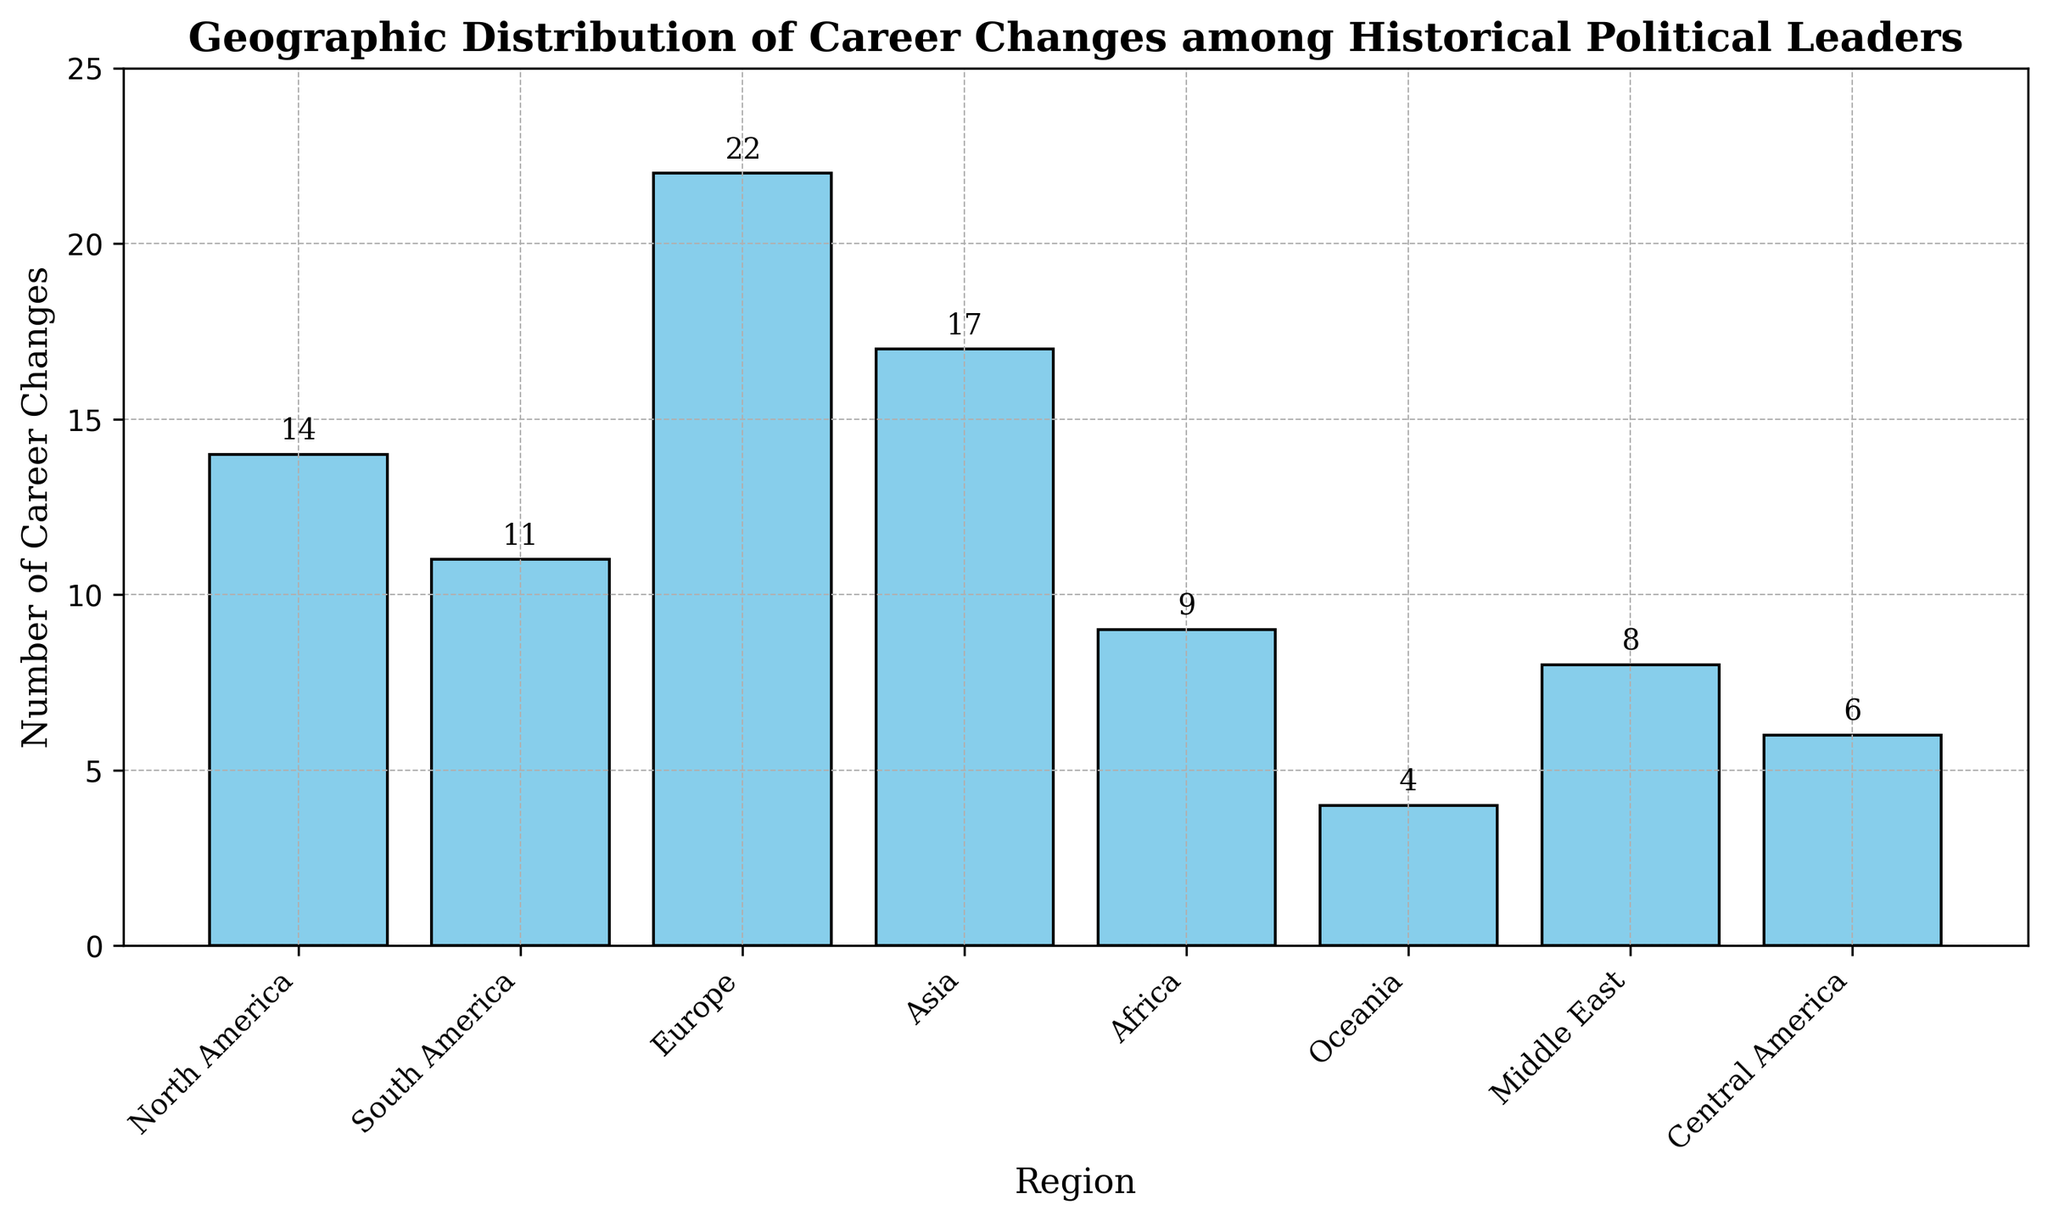What region had the highest number of career changes among historical political leaders? The region with the tallest bar represents the highest number of career changes. From the figure, Europe has the tallest bar, indicating it has the highest number of career changes.
Answer: Europe Compare the number of career changes between Asia and Africa. Which one is greater, and by how much? The height of the bar for Asia is 17 and for Africa is 9. Subtract the number of career changes in Africa from the number in Asia (17 - 9) to find the difference.
Answer: Asia has 8 more than Africa What is the total number of career changes for the regions North America and South America combined? From the figure, North America has 14 career changes and South America has 11. Add these two values (14 + 11 = 25).
Answer: 25 How many regions have fewer than 10 career changes? Identify and count the bars that represent fewer than 10 career changes. Africa (9), Oceania (4), Middle East (8), and Central America (6) all have fewer than 10. There are four regions in total.
Answer: 4 What is the average number of career changes across all regions? Sum up the number of career changes for all regions (14 + 11 + 22 + 17 + 9 + 4 + 8 + 6 = 91), then divide by the number of regions (8). 91 divided by 8 is approximately 11.38.
Answer: 11.38 Which region has the fewest career changes, and what is the value? The region with the shortest bar represents the fewest number of career changes. From the figure, Oceania has the shortest bar with 4 career changes.
Answer: Oceania, 4 